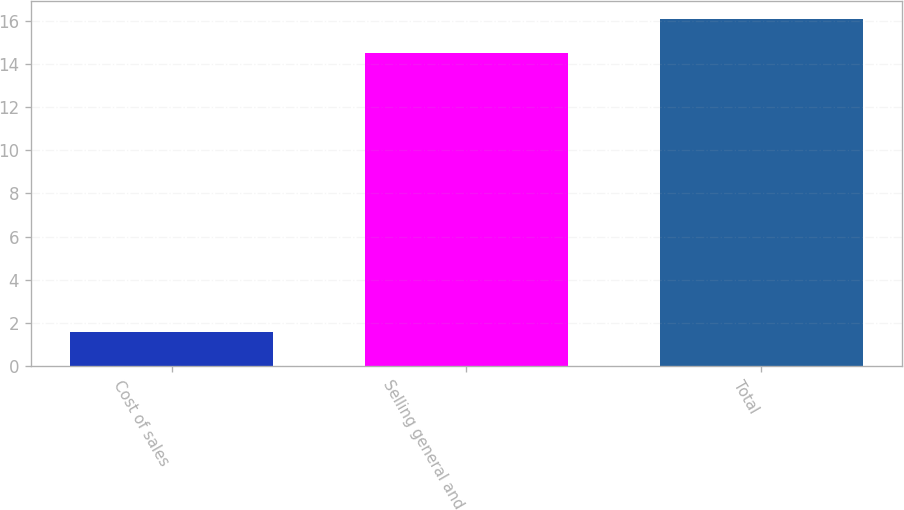Convert chart. <chart><loc_0><loc_0><loc_500><loc_500><bar_chart><fcel>Cost of sales<fcel>Selling general and<fcel>Total<nl><fcel>1.6<fcel>14.5<fcel>16.1<nl></chart> 